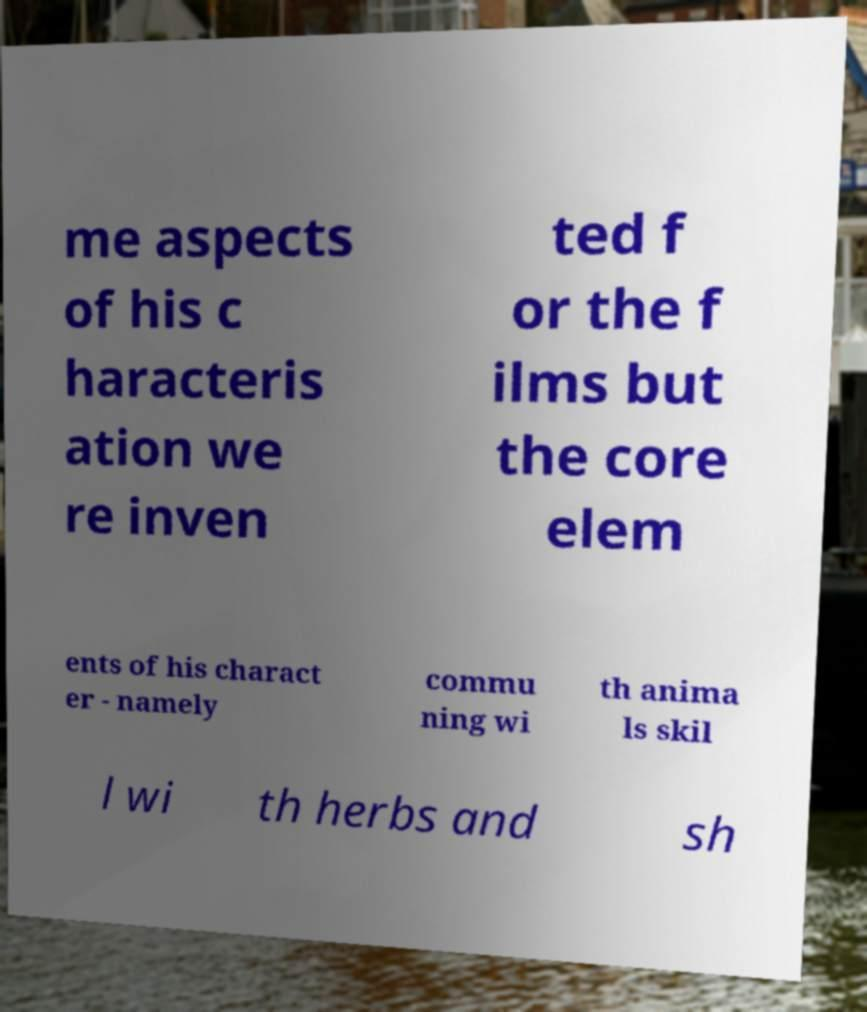What messages or text are displayed in this image? I need them in a readable, typed format. me aspects of his c haracteris ation we re inven ted f or the f ilms but the core elem ents of his charact er - namely commu ning wi th anima ls skil l wi th herbs and sh 